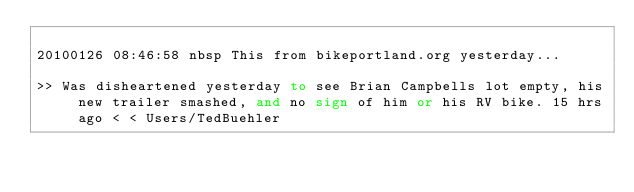Convert code to text. <code><loc_0><loc_0><loc_500><loc_500><_FORTRAN_>
20100126 08:46:58 nbsp This from bikeportland.org yesterday...

>> Was disheartened yesterday to see Brian Campbells lot empty, his new trailer smashed, and no sign of him or his RV bike. 15 hrs ago < < Users/TedBuehler
</code> 